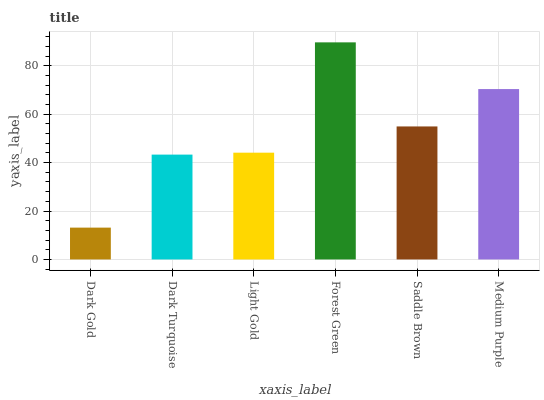Is Dark Gold the minimum?
Answer yes or no. Yes. Is Forest Green the maximum?
Answer yes or no. Yes. Is Dark Turquoise the minimum?
Answer yes or no. No. Is Dark Turquoise the maximum?
Answer yes or no. No. Is Dark Turquoise greater than Dark Gold?
Answer yes or no. Yes. Is Dark Gold less than Dark Turquoise?
Answer yes or no. Yes. Is Dark Gold greater than Dark Turquoise?
Answer yes or no. No. Is Dark Turquoise less than Dark Gold?
Answer yes or no. No. Is Saddle Brown the high median?
Answer yes or no. Yes. Is Light Gold the low median?
Answer yes or no. Yes. Is Dark Turquoise the high median?
Answer yes or no. No. Is Saddle Brown the low median?
Answer yes or no. No. 